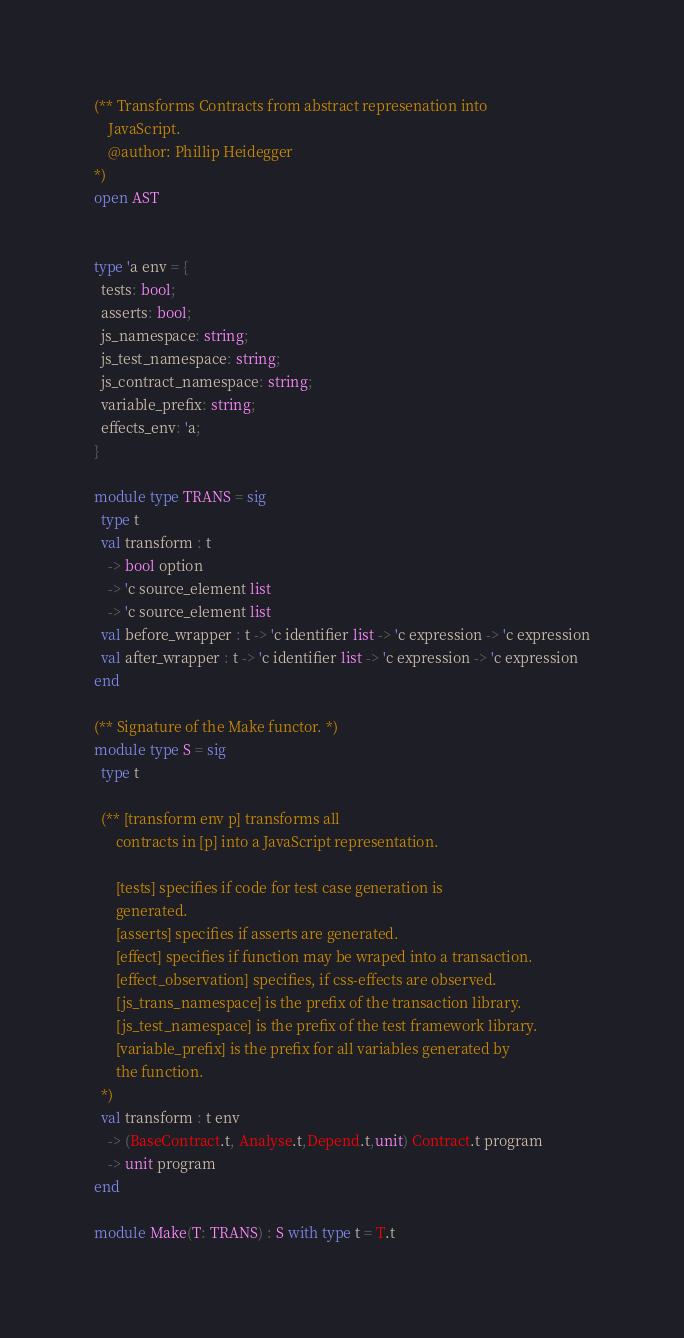Convert code to text. <code><loc_0><loc_0><loc_500><loc_500><_OCaml_>(** Transforms Contracts from abstract represenation into
    JavaScript. 
    @author: Phillip Heidegger
*)
open AST


type 'a env = {
  tests: bool;
  asserts: bool;
  js_namespace: string;
  js_test_namespace: string;
  js_contract_namespace: string;
  variable_prefix: string;
  effects_env: 'a;
}

module type TRANS = sig
  type t
  val transform : t 
    -> bool option 
    -> 'c source_element list 
    -> 'c source_element list
  val before_wrapper : t -> 'c identifier list -> 'c expression -> 'c expression
  val after_wrapper : t -> 'c identifier list -> 'c expression -> 'c expression
end

(** Signature of the Make functor. *)  
module type S = sig
  type t

  (** [transform env p] transforms all 
      contracts in [p] into a JavaScript representation. 
      
      [tests] specifies if code for test case generation is
      generated.
      [asserts] specifies if asserts are generated.
      [effect] specifies if function may be wraped into a transaction.
      [effect_observation] specifies, if css-effects are observed.
      [js_trans_namespace] is the prefix of the transaction library.
      [js_test_namespace] is the prefix of the test framework library.
      [variable_prefix] is the prefix for all variables generated by
      the function.
  *)
  val transform : t env
    -> (BaseContract.t, Analyse.t,Depend.t,unit) Contract.t program 
    -> unit program
end

module Make(T: TRANS) : S with type t = T.t
</code> 